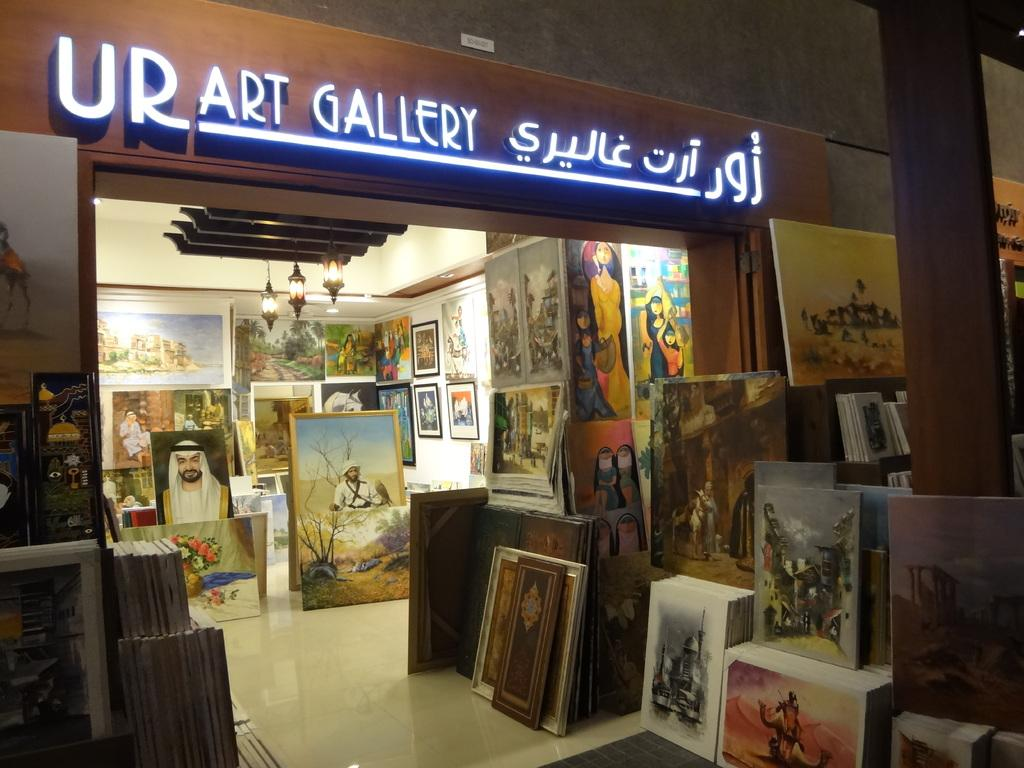What type of establishment is shown in the image? There is a store in the image. What can be seen inside the store? Frames are visible in the image. What type of lighting is present in the store? There are lights at the top of the image. Is there any signage or information displayed in the store? Yes, there is a board visible in the image. What shape does the sun have in the image? The image does not show the sun, so it is not possible to determine its shape. 